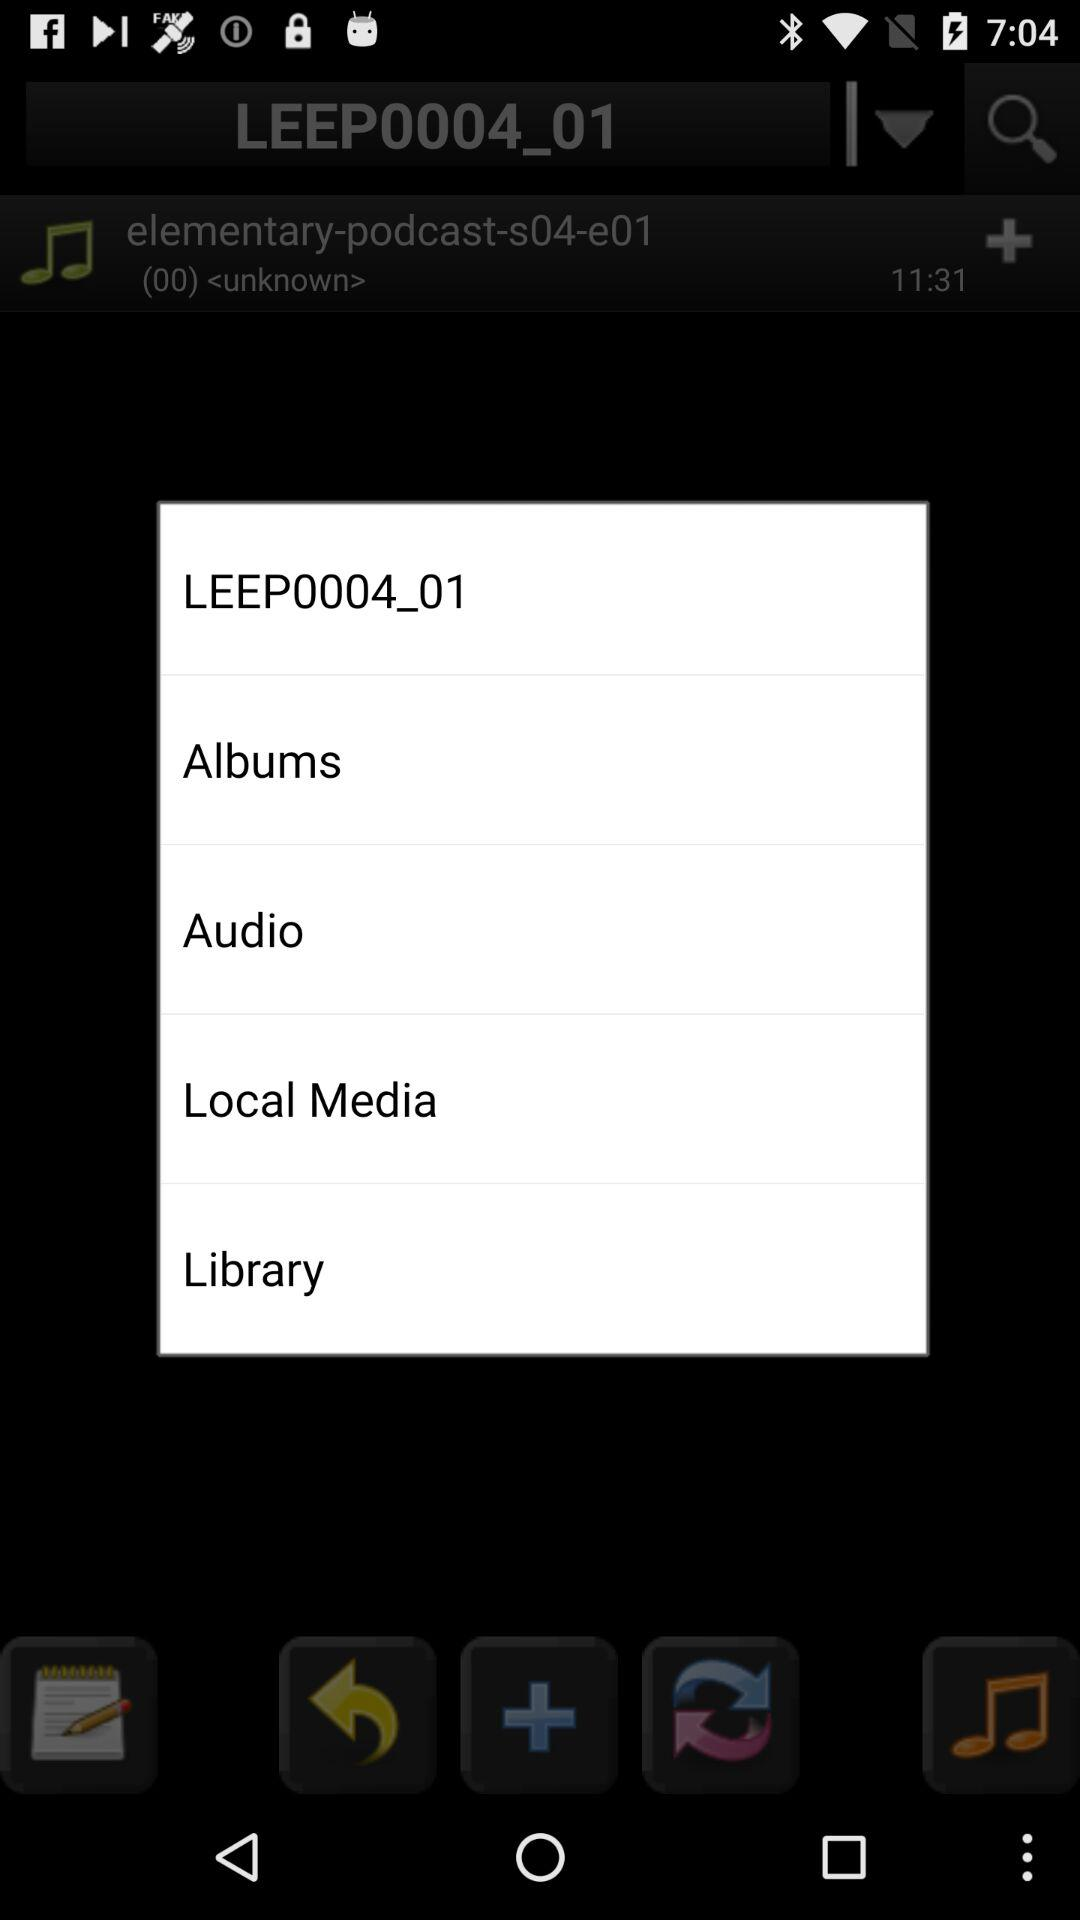What is the time duration of the audio? The duration of the audio is 11 minutes and 31 seconds. 